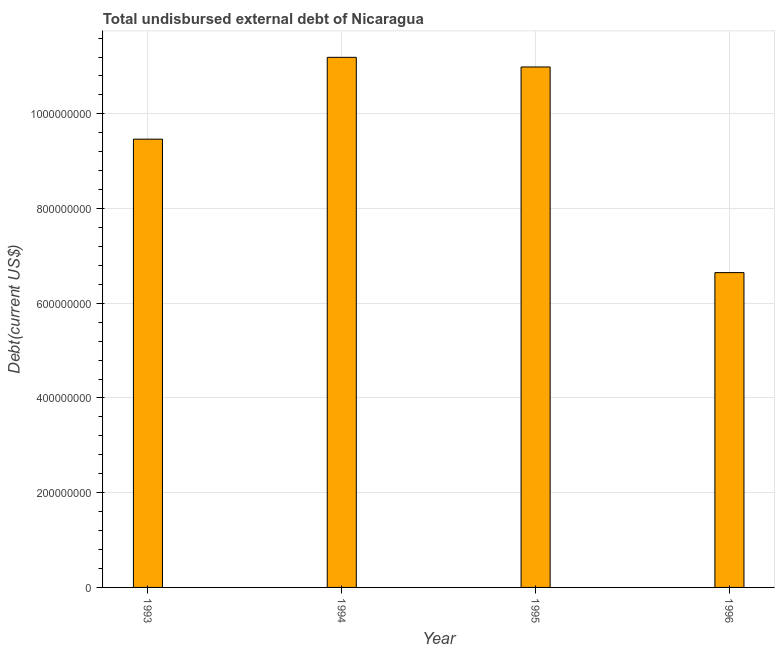Does the graph contain any zero values?
Ensure brevity in your answer.  No. What is the title of the graph?
Your answer should be compact. Total undisbursed external debt of Nicaragua. What is the label or title of the Y-axis?
Make the answer very short. Debt(current US$). What is the total debt in 1995?
Ensure brevity in your answer.  1.10e+09. Across all years, what is the maximum total debt?
Your response must be concise. 1.12e+09. Across all years, what is the minimum total debt?
Provide a succinct answer. 6.65e+08. What is the sum of the total debt?
Keep it short and to the point. 3.83e+09. What is the difference between the total debt in 1993 and 1994?
Your response must be concise. -1.73e+08. What is the average total debt per year?
Provide a succinct answer. 9.57e+08. What is the median total debt?
Your answer should be very brief. 1.02e+09. Do a majority of the years between 1995 and 1994 (inclusive) have total debt greater than 1080000000 US$?
Give a very brief answer. No. What is the ratio of the total debt in 1994 to that in 1995?
Your answer should be very brief. 1.02. Is the total debt in 1995 less than that in 1996?
Your answer should be very brief. No. Is the difference between the total debt in 1993 and 1996 greater than the difference between any two years?
Offer a terse response. No. What is the difference between the highest and the second highest total debt?
Make the answer very short. 2.04e+07. What is the difference between the highest and the lowest total debt?
Offer a terse response. 4.55e+08. How many bars are there?
Provide a succinct answer. 4. Are all the bars in the graph horizontal?
Give a very brief answer. No. How many years are there in the graph?
Keep it short and to the point. 4. Are the values on the major ticks of Y-axis written in scientific E-notation?
Offer a terse response. No. What is the Debt(current US$) of 1993?
Ensure brevity in your answer.  9.47e+08. What is the Debt(current US$) of 1994?
Offer a very short reply. 1.12e+09. What is the Debt(current US$) of 1995?
Provide a short and direct response. 1.10e+09. What is the Debt(current US$) of 1996?
Your response must be concise. 6.65e+08. What is the difference between the Debt(current US$) in 1993 and 1994?
Offer a terse response. -1.73e+08. What is the difference between the Debt(current US$) in 1993 and 1995?
Keep it short and to the point. -1.52e+08. What is the difference between the Debt(current US$) in 1993 and 1996?
Provide a short and direct response. 2.82e+08. What is the difference between the Debt(current US$) in 1994 and 1995?
Your response must be concise. 2.04e+07. What is the difference between the Debt(current US$) in 1994 and 1996?
Ensure brevity in your answer.  4.55e+08. What is the difference between the Debt(current US$) in 1995 and 1996?
Offer a terse response. 4.34e+08. What is the ratio of the Debt(current US$) in 1993 to that in 1994?
Offer a terse response. 0.85. What is the ratio of the Debt(current US$) in 1993 to that in 1995?
Your response must be concise. 0.86. What is the ratio of the Debt(current US$) in 1993 to that in 1996?
Your answer should be very brief. 1.42. What is the ratio of the Debt(current US$) in 1994 to that in 1996?
Offer a very short reply. 1.68. What is the ratio of the Debt(current US$) in 1995 to that in 1996?
Provide a succinct answer. 1.65. 